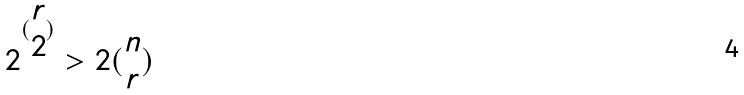Convert formula to latex. <formula><loc_0><loc_0><loc_500><loc_500>2 ^ { ( \begin{matrix} r \\ 2 \end{matrix} ) } > 2 ( \begin{matrix} n \\ r \end{matrix} )</formula> 